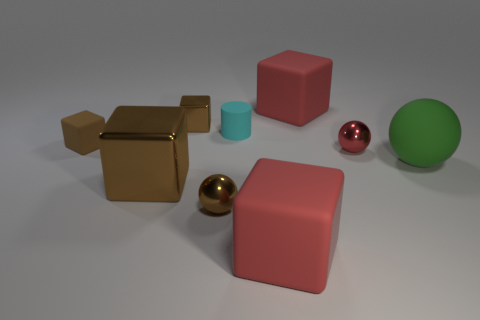Subtract all metal spheres. How many spheres are left? 1 Add 1 small gray metal blocks. How many objects exist? 10 Subtract all red spheres. How many spheres are left? 2 Subtract 1 balls. How many balls are left? 2 Subtract all spheres. How many objects are left? 6 Subtract all brown cylinders. How many brown blocks are left? 3 Subtract all large green rubber things. Subtract all big brown blocks. How many objects are left? 7 Add 1 small rubber cylinders. How many small rubber cylinders are left? 2 Add 5 small matte things. How many small matte things exist? 7 Subtract 0 yellow cylinders. How many objects are left? 9 